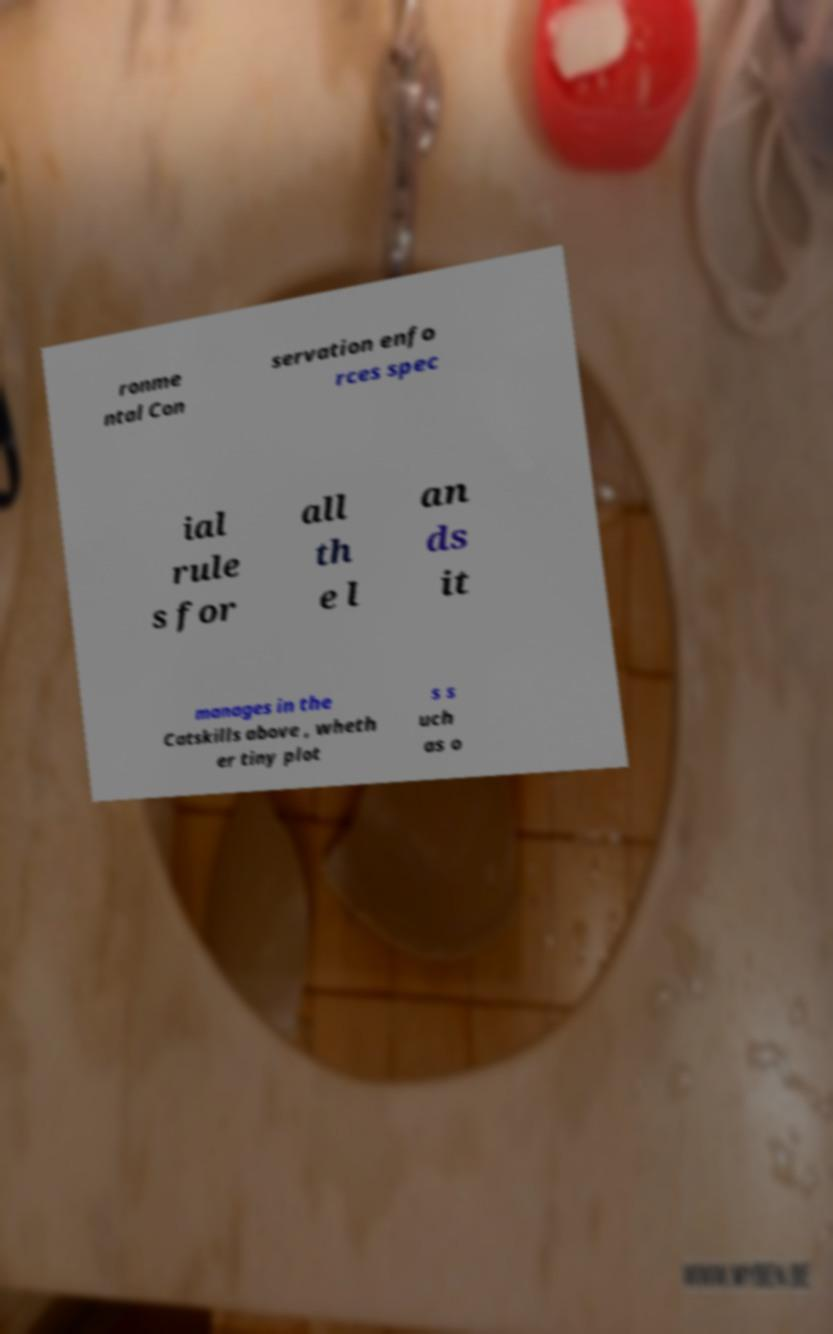I need the written content from this picture converted into text. Can you do that? ronme ntal Con servation enfo rces spec ial rule s for all th e l an ds it manages in the Catskills above , wheth er tiny plot s s uch as o 